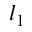<formula> <loc_0><loc_0><loc_500><loc_500>l _ { 1 }</formula> 